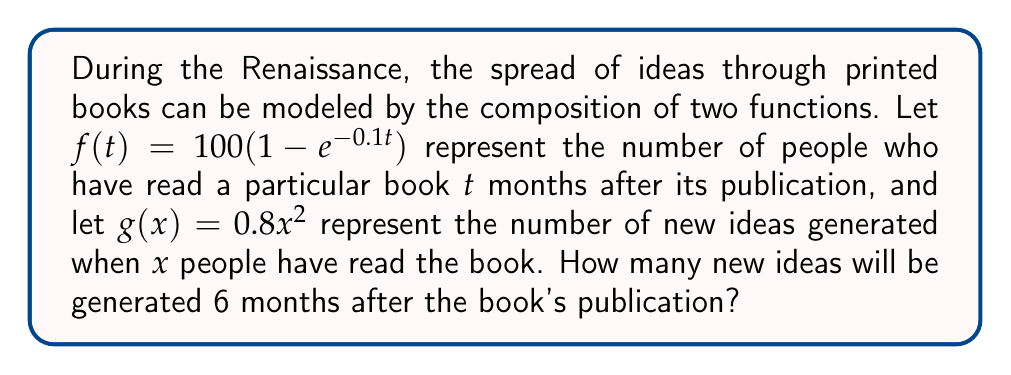Give your solution to this math problem. To solve this problem, we need to follow these steps:

1) First, we need to find $f(6)$, which represents the number of people who have read the book after 6 months:

   $f(6) = 100(1 - e^{-0.1(6)})$
   $f(6) = 100(1 - e^{-0.6})$
   $f(6) = 100(1 - 0.5488)$
   $f(6) = 45.12$

2) Now that we know how many people have read the book after 6 months, we need to use this as input for function $g$:

   $g(f(6)) = 0.8(45.12)^2$

3) Let's calculate this:

   $g(f(6)) = 0.8(2035.8144)$
   $g(f(6)) = 1628.65152$

Therefore, approximately 1628.65 new ideas will be generated 6 months after the book's publication.
Answer: 1628.65 